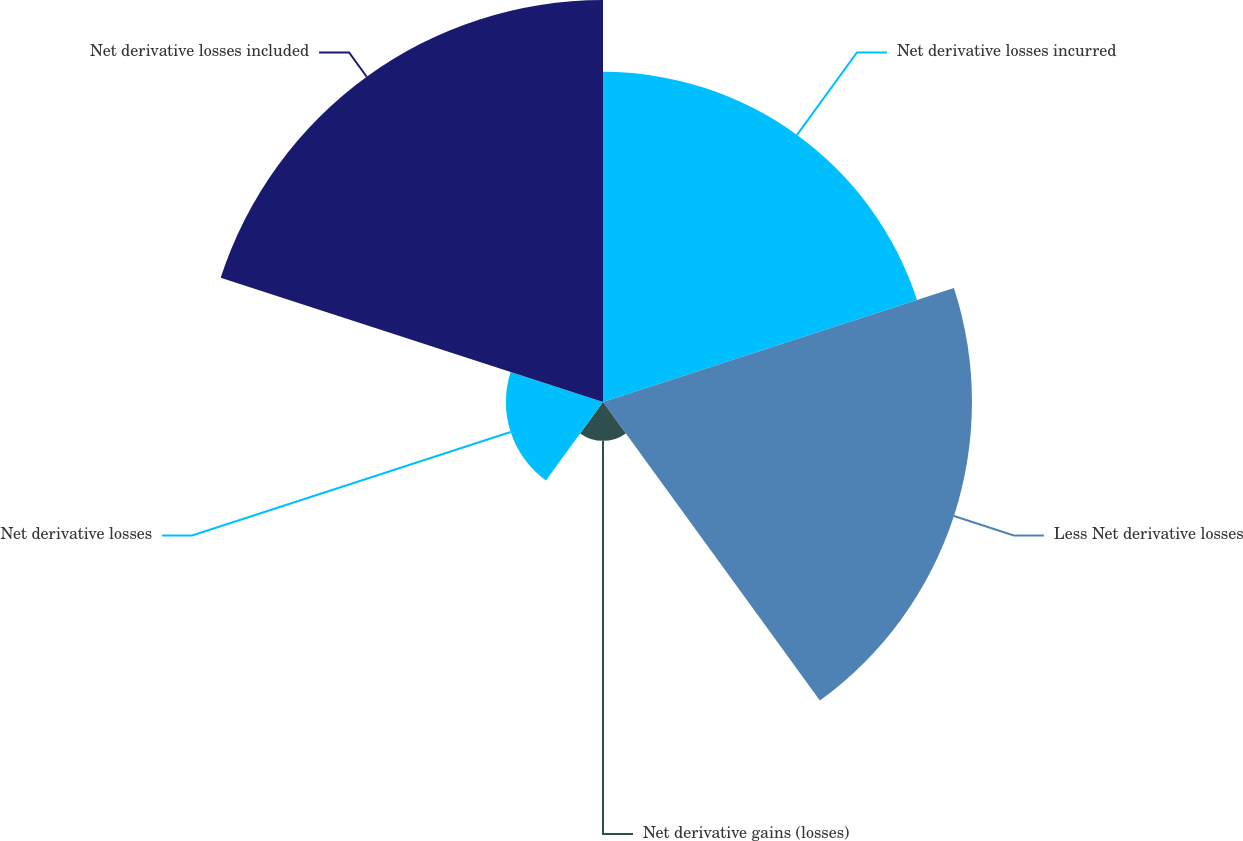Convert chart to OTSL. <chart><loc_0><loc_0><loc_500><loc_500><pie_chart><fcel>Net derivative losses incurred<fcel>Less Net derivative losses<fcel>Net derivative gains (losses)<fcel>Net derivative losses<fcel>Net derivative losses included<nl><fcel>26.69%<fcel>29.83%<fcel>3.14%<fcel>7.85%<fcel>32.5%<nl></chart> 